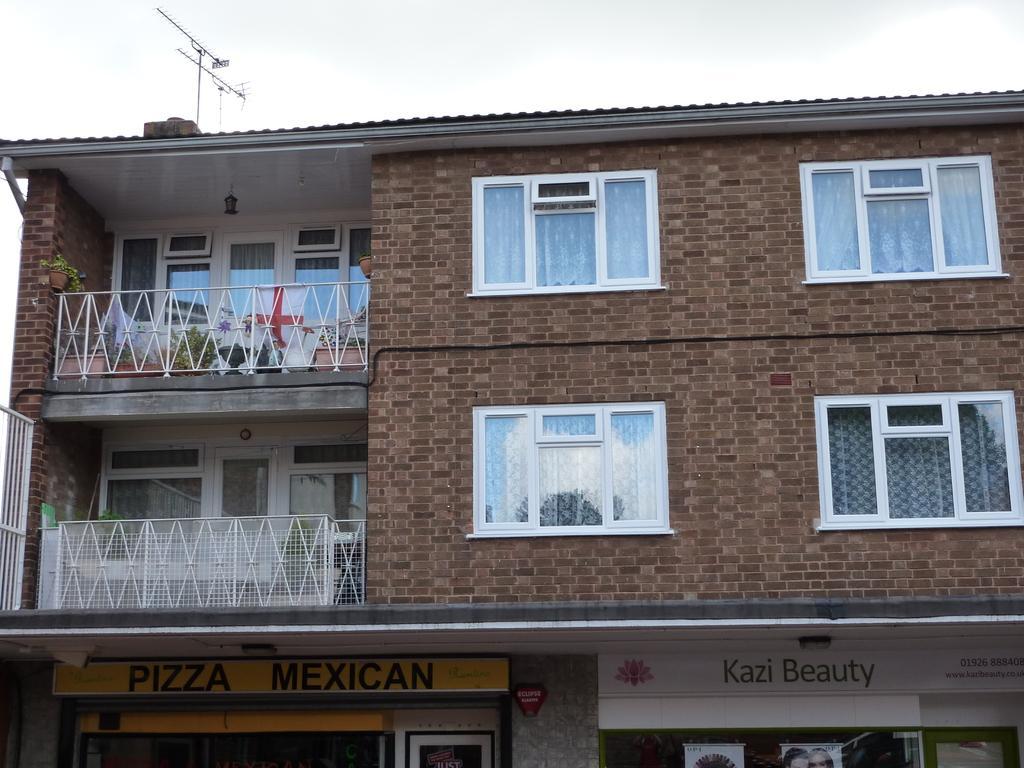Can you describe this image briefly? In the image there is a building and under the building there are two stores. 